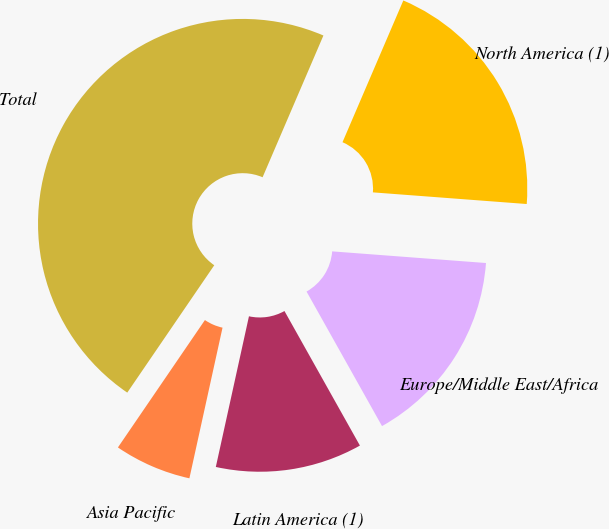Convert chart. <chart><loc_0><loc_0><loc_500><loc_500><pie_chart><fcel>North America (1)<fcel>Europe/Middle East/Africa<fcel>Latin America (1)<fcel>Asia Pacific<fcel>Total<nl><fcel>19.75%<fcel>15.66%<fcel>11.58%<fcel>6.09%<fcel>46.91%<nl></chart> 